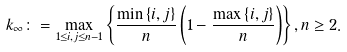Convert formula to latex. <formula><loc_0><loc_0><loc_500><loc_500>k _ { \infty } \colon = \max _ { 1 \leq i , j \leq n - 1 } \left \{ \frac { \min \left \{ i , j \right \} } { n } \left ( 1 - \frac { \max \left \{ i , j \right \} } { n } \right ) \right \} , n \geq 2 .</formula> 